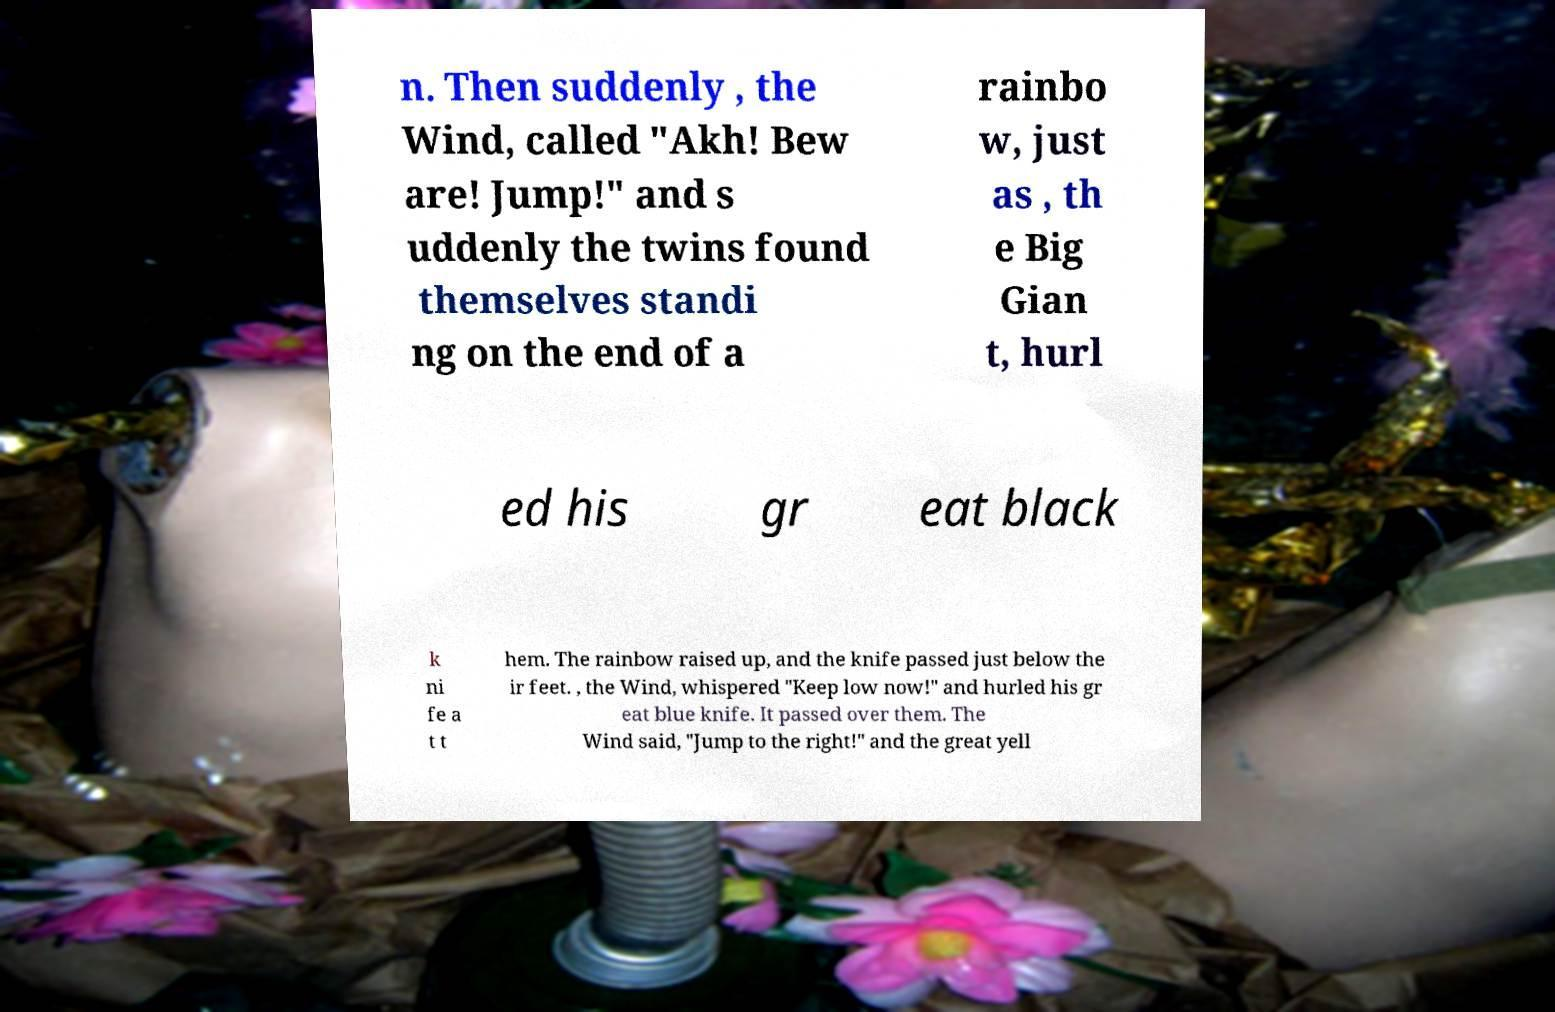Could you assist in decoding the text presented in this image and type it out clearly? n. Then suddenly , the Wind, called "Akh! Bew are! Jump!" and s uddenly the twins found themselves standi ng on the end of a rainbo w, just as , th e Big Gian t, hurl ed his gr eat black k ni fe a t t hem. The rainbow raised up, and the knife passed just below the ir feet. , the Wind, whispered "Keep low now!" and hurled his gr eat blue knife. It passed over them. The Wind said, "Jump to the right!" and the great yell 